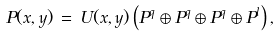Convert formula to latex. <formula><loc_0><loc_0><loc_500><loc_500>P ( x , y ) \, = \, U ( x , y ) \left ( P ^ { q } \oplus P ^ { q } \oplus P ^ { q } \oplus P ^ { l } \right ) ,</formula> 